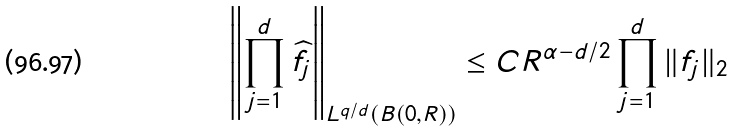Convert formula to latex. <formula><loc_0><loc_0><loc_500><loc_500>\left \| \prod _ { j = 1 } ^ { d } \widehat { f } _ { j } \right \| _ { L ^ { q / d } ( B ( 0 , R ) ) } \leq C R ^ { \alpha - d / 2 } \prod _ { j = 1 } ^ { d } \| f _ { j } \| _ { 2 }</formula> 